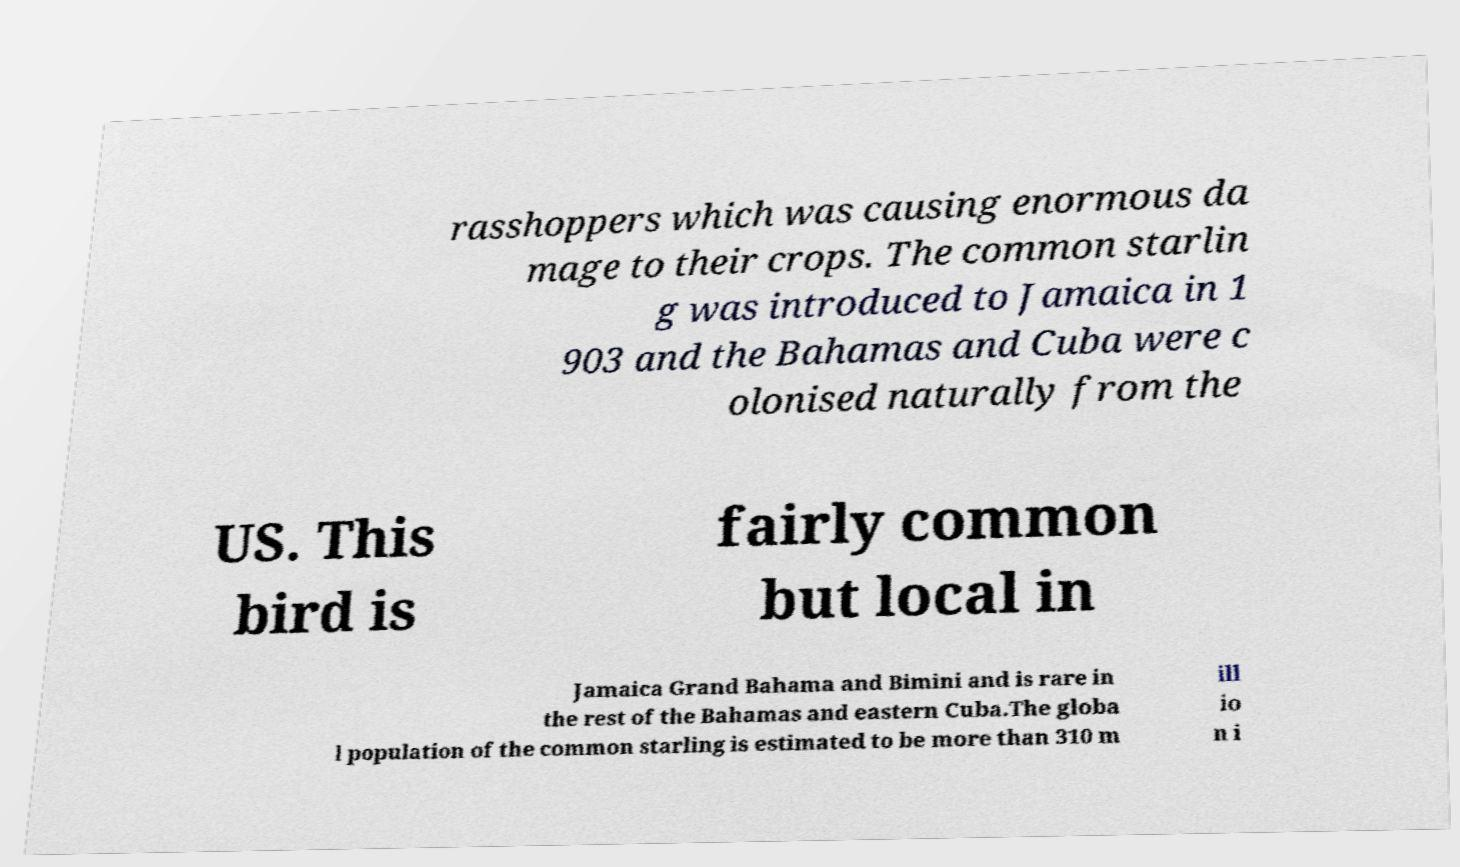Please read and relay the text visible in this image. What does it say? rasshoppers which was causing enormous da mage to their crops. The common starlin g was introduced to Jamaica in 1 903 and the Bahamas and Cuba were c olonised naturally from the US. This bird is fairly common but local in Jamaica Grand Bahama and Bimini and is rare in the rest of the Bahamas and eastern Cuba.The globa l population of the common starling is estimated to be more than 310 m ill io n i 